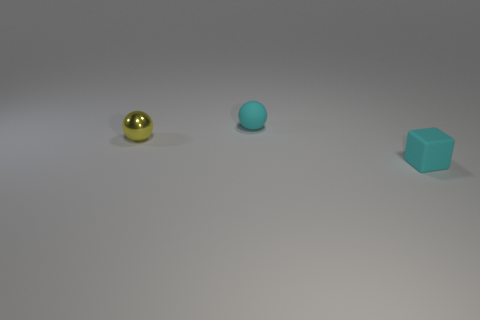Add 3 yellow shiny balls. How many objects exist? 6 Subtract all yellow balls. How many balls are left? 1 Subtract 1 spheres. How many spheres are left? 1 Subtract all balls. How many objects are left? 1 Subtract all purple cubes. Subtract all purple spheres. How many cubes are left? 1 Subtract all blue cylinders. How many yellow balls are left? 1 Subtract all large gray objects. Subtract all small cyan cubes. How many objects are left? 2 Add 1 small things. How many small things are left? 4 Add 1 blocks. How many blocks exist? 2 Subtract 0 green cylinders. How many objects are left? 3 